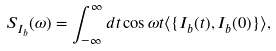<formula> <loc_0><loc_0><loc_500><loc_500>S _ { I _ { b } } ( \omega ) = \int _ { - \infty } ^ { \infty } d t \cos \omega t \langle \{ I _ { b } ( t ) , I _ { b } ( 0 ) \} \rangle ,</formula> 